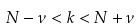Convert formula to latex. <formula><loc_0><loc_0><loc_500><loc_500>N - \nu < k < N + \nu</formula> 